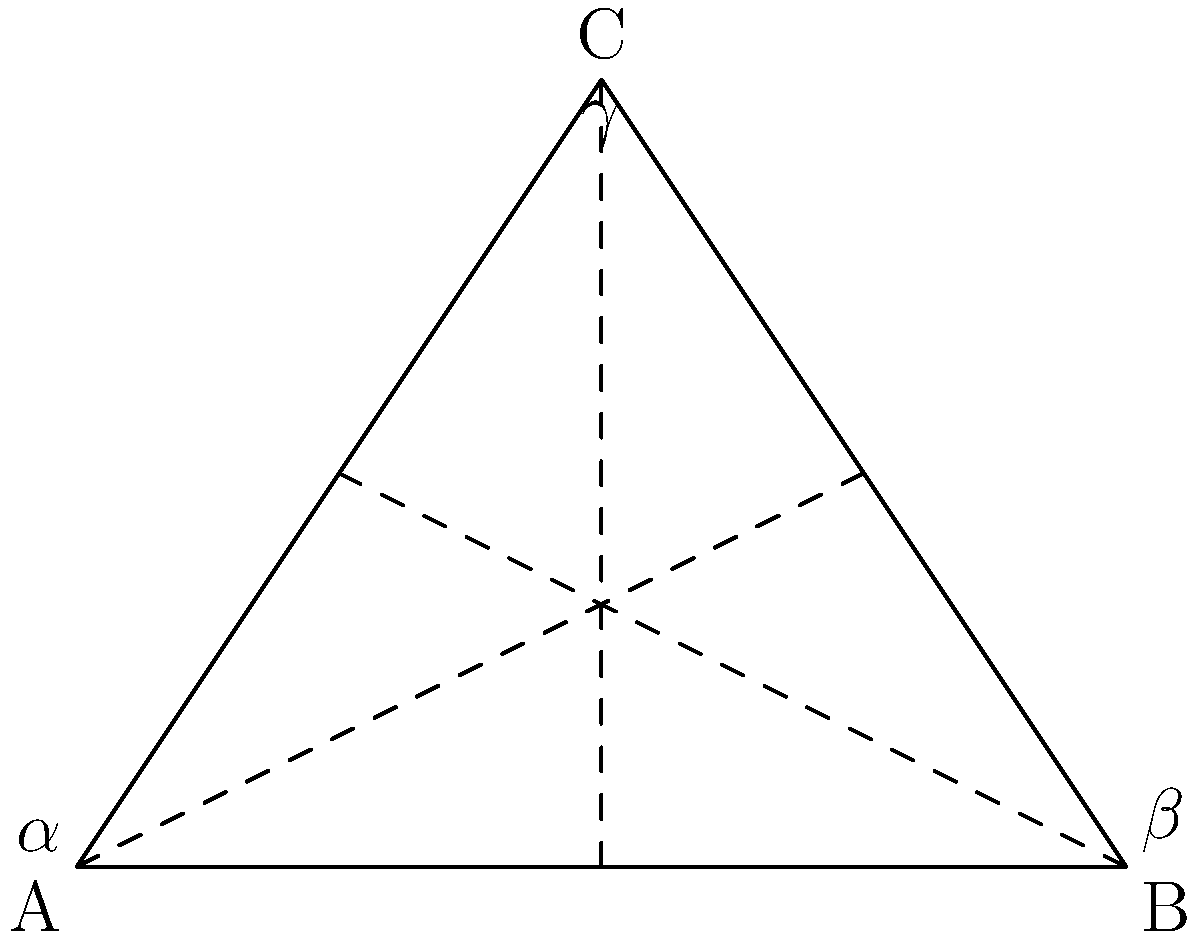In hyperbolic geometry, consider a triangle ABC with angles $\alpha$, $\beta$, and $\gamma$ as shown in the figure. If the area of the triangle is 0.3 radians squared, calculate the sum of the interior angles $\alpha + \beta + \gamma$ in radians. To solve this problem, we'll use the Gauss-Bonnet theorem for hyperbolic triangles. The steps are as follows:

1) In hyperbolic geometry, the Gauss-Bonnet theorem states that:

   $$A + \alpha + \beta + \gamma = \pi$$

   Where $A$ is the area of the triangle, and $\alpha$, $\beta$, $\gamma$ are the interior angles.

2) We are given that the area $A = 0.3$ radians squared.

3) Substituting this into the equation:

   $$0.3 + \alpha + \beta + \gamma = \pi$$

4) Rearranging to solve for the sum of the angles:

   $$\alpha + \beta + \gamma = \pi - 0.3$$

5) We know that $\pi \approx 3.14159$, so:

   $$\alpha + \beta + \gamma = 3.14159 - 0.3 = 2.84159$$

Therefore, the sum of the interior angles of this hyperbolic triangle is approximately 2.84159 radians.
Answer: $2.84159$ radians 